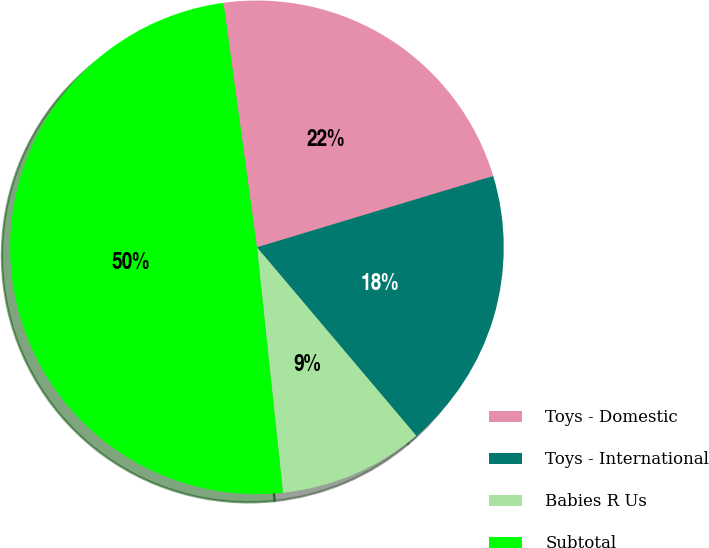Convert chart. <chart><loc_0><loc_0><loc_500><loc_500><pie_chart><fcel>Toys - Domestic<fcel>Toys - International<fcel>Babies R Us<fcel>Subtotal<nl><fcel>22.5%<fcel>18.5%<fcel>9.49%<fcel>49.52%<nl></chart> 